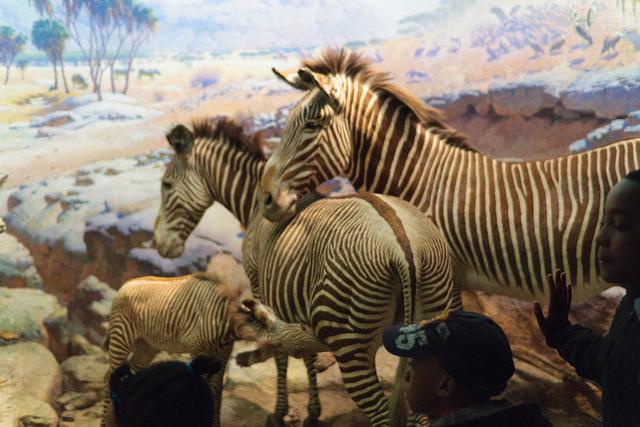How many zebras are there?
Short answer required. 3. What are the zebras doing?
Write a very short answer. Standing. Where is the baby Zebra?
Give a very brief answer. Left. 